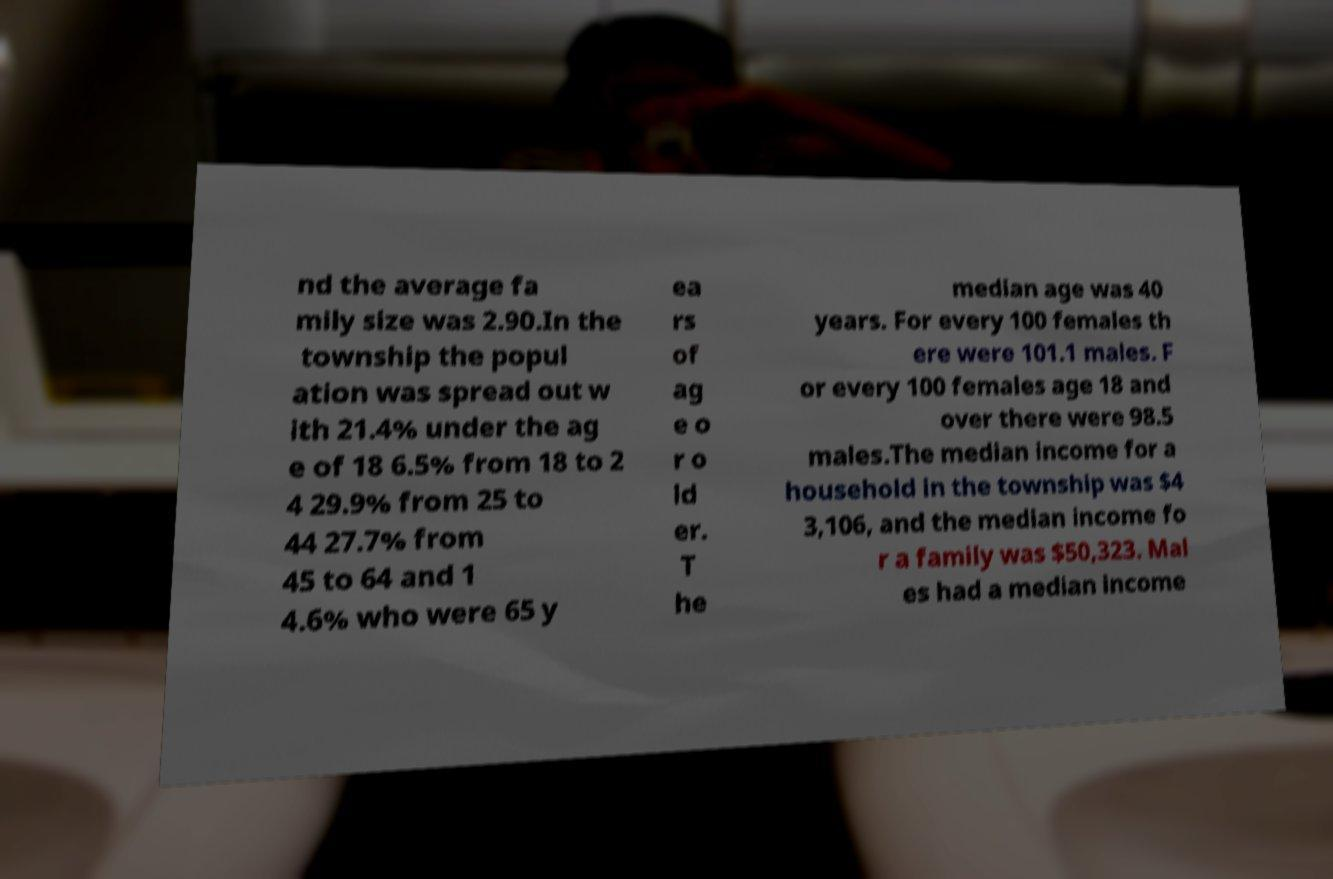For documentation purposes, I need the text within this image transcribed. Could you provide that? nd the average fa mily size was 2.90.In the township the popul ation was spread out w ith 21.4% under the ag e of 18 6.5% from 18 to 2 4 29.9% from 25 to 44 27.7% from 45 to 64 and 1 4.6% who were 65 y ea rs of ag e o r o ld er. T he median age was 40 years. For every 100 females th ere were 101.1 males. F or every 100 females age 18 and over there were 98.5 males.The median income for a household in the township was $4 3,106, and the median income fo r a family was $50,323. Mal es had a median income 